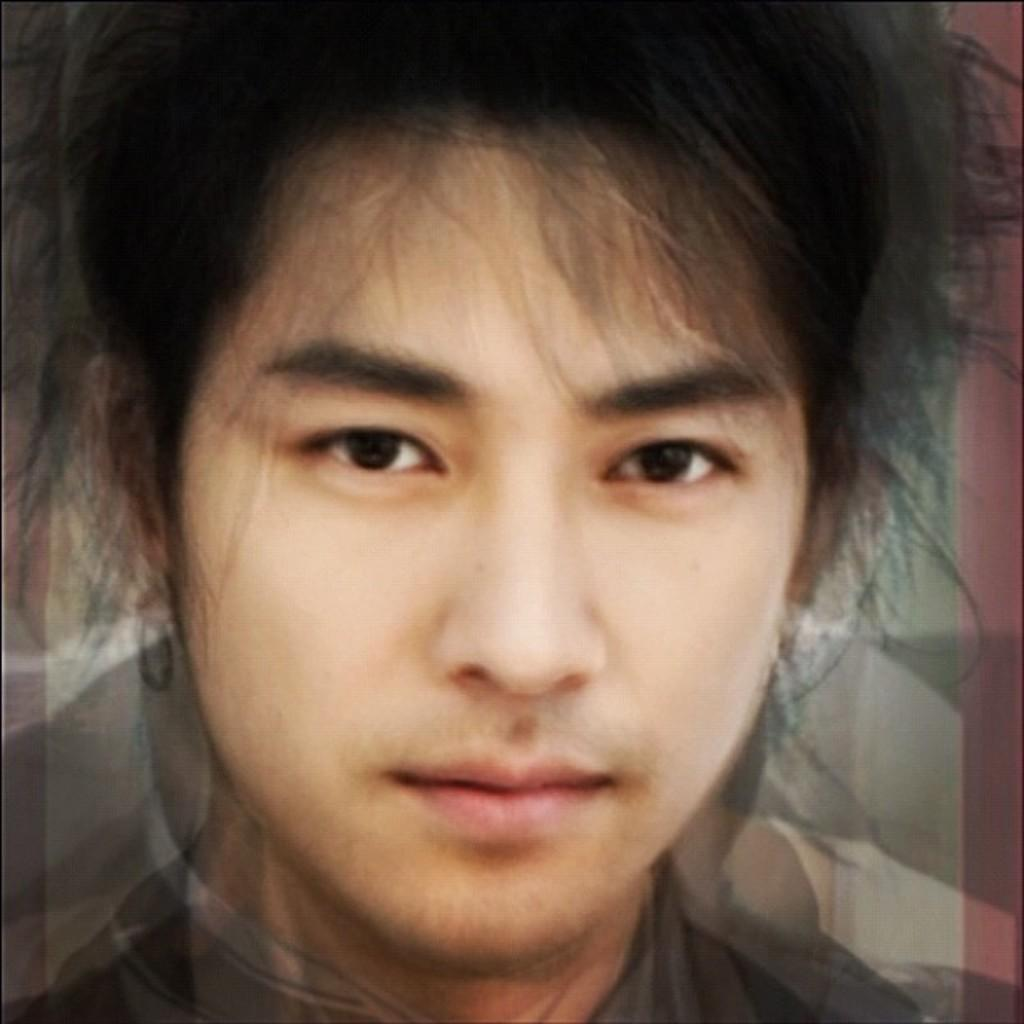What is the main subject of the image? There is a person's face in the image. What type of reading material is the person holding in the image? There is no reading material present in the image; it only features a person's face. How many roses can be seen in the image? There are no roses present in the image; it only features a person's face. 